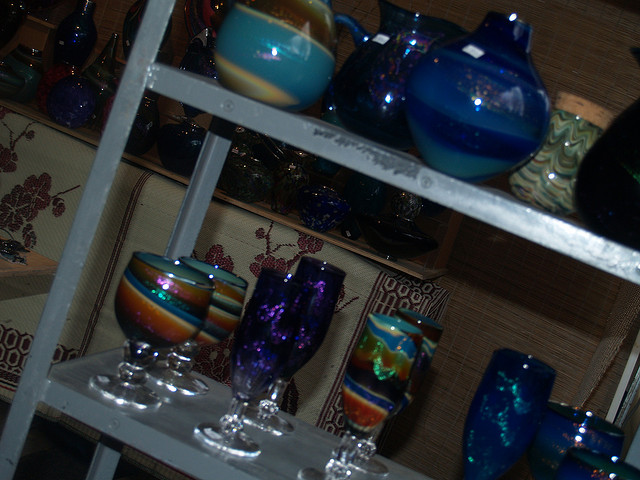<image>What kind of flowers are show? I don't know what kind of flowers are shown. It could be roses, cherry blossoms or poppies. Is the front shelf a new item or a used item? I don't know if the front shelf is a new item or a used item. What kind of flowers are show? I am not sure what kind of flowers are shown. Is the front shelf a new item or a used item? It is ambiguous whether the front shelf is a new item or a used item. 